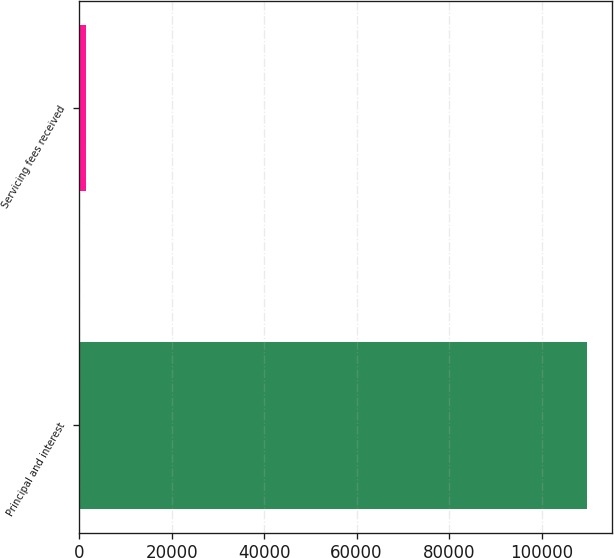Convert chart. <chart><loc_0><loc_0><loc_500><loc_500><bar_chart><fcel>Principal and interest<fcel>Servicing fees received<nl><fcel>109779<fcel>1571<nl></chart> 